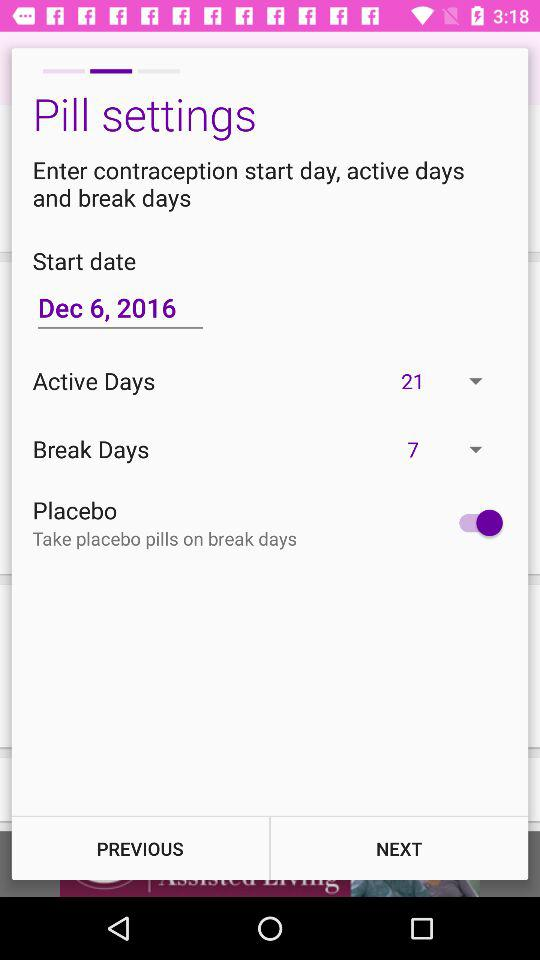How many active days are there? There are 21 active days. 